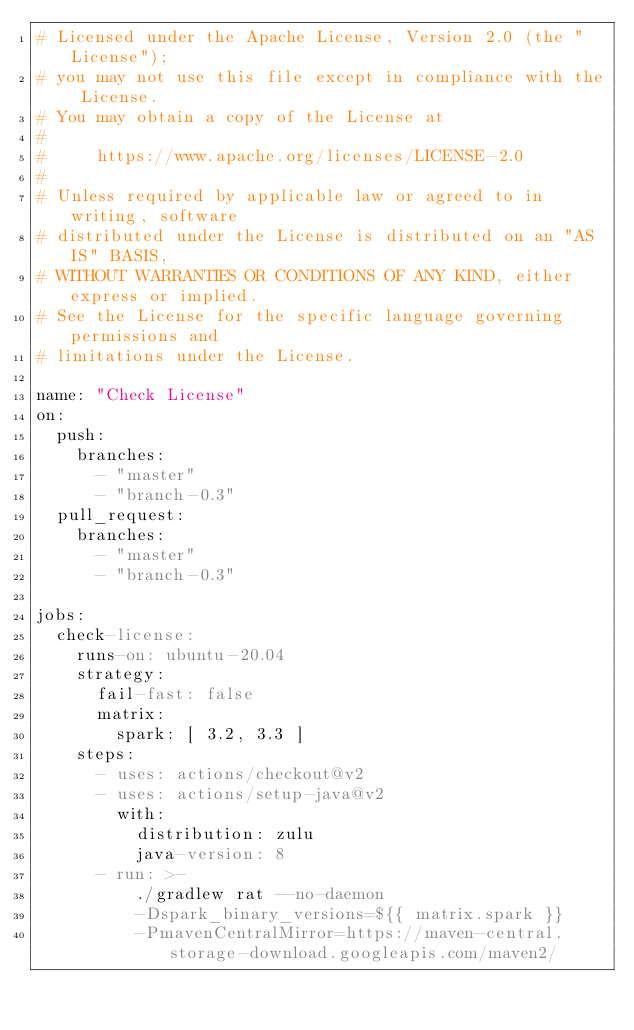Convert code to text. <code><loc_0><loc_0><loc_500><loc_500><_YAML_># Licensed under the Apache License, Version 2.0 (the "License");
# you may not use this file except in compliance with the License.
# You may obtain a copy of the License at
#
#     https://www.apache.org/licenses/LICENSE-2.0
#
# Unless required by applicable law or agreed to in writing, software
# distributed under the License is distributed on an "AS IS" BASIS,
# WITHOUT WARRANTIES OR CONDITIONS OF ANY KIND, either express or implied.
# See the License for the specific language governing permissions and
# limitations under the License.

name: "Check License"
on:
  push:
    branches:
      - "master"
      - "branch-0.3"
  pull_request:
    branches:
      - "master"
      - "branch-0.3"

jobs:
  check-license:
    runs-on: ubuntu-20.04
    strategy:
      fail-fast: false
      matrix:
        spark: [ 3.2, 3.3 ]
    steps:
      - uses: actions/checkout@v2
      - uses: actions/setup-java@v2
        with:
          distribution: zulu
          java-version: 8
      - run: >-
          ./gradlew rat --no-daemon
          -Dspark_binary_versions=${{ matrix.spark }}
          -PmavenCentralMirror=https://maven-central.storage-download.googleapis.com/maven2/
</code> 